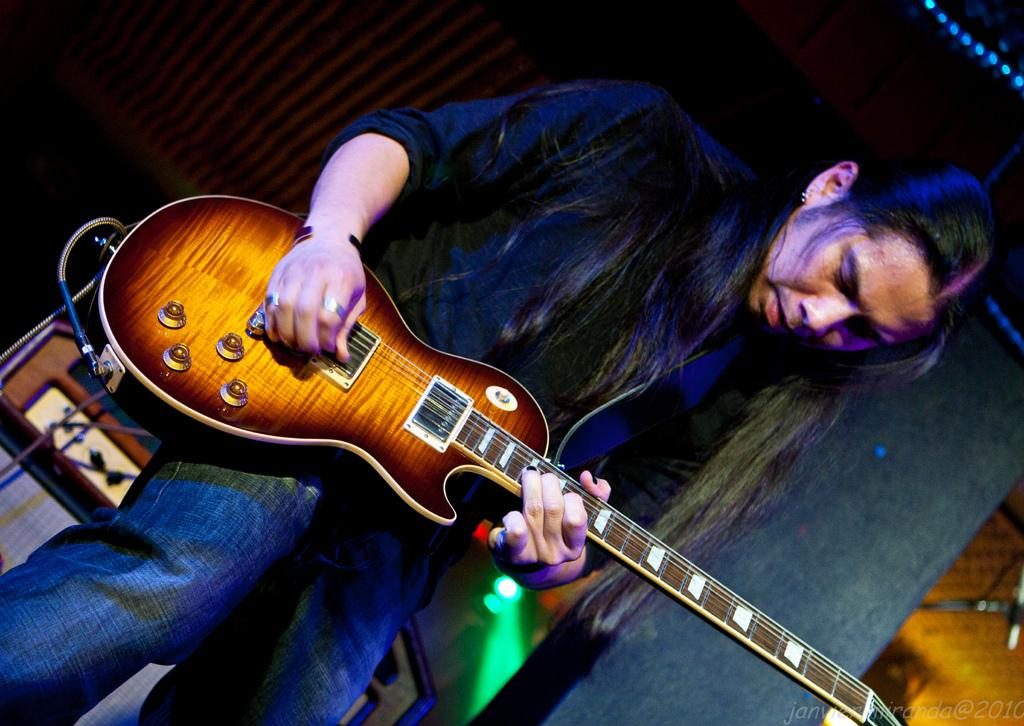What is the person in the image doing? The person is holding a guitar. What is the person's posture or gaze in the image? The person is looking downwards. What can be seen in the background of the image? There is a table in the background of the image. What type of toys can be seen scattered around the person's feet in the image? There are no toys present in the image, and the person's feet are not visible. How does the person react to the rainstorm in the image? There is no rainstorm present in the image, so the person's reaction cannot be determined. 